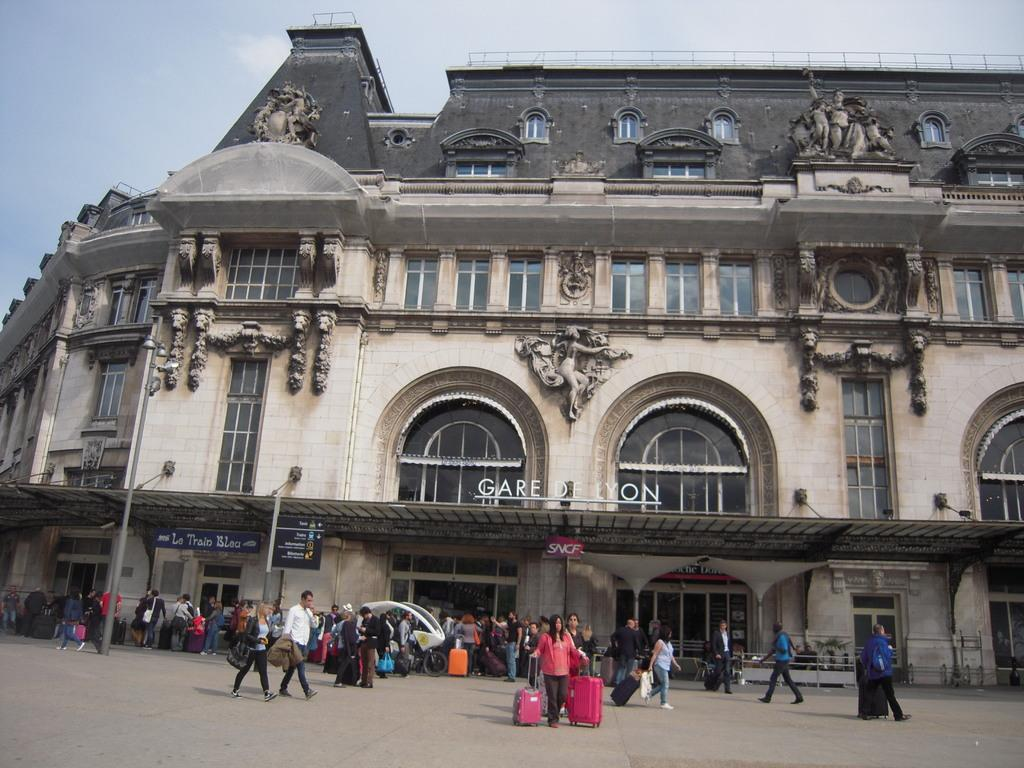What are the people in the image doing? The people in the image are walking on the road. Can you describe the building in the image? The building in the image has many windows and doors. What can be seen in the sky in the image? The sky is visible in the image. How many cakes are being carried by the creature in the image? There is no creature present in the image, and therefore no cakes are being carried. 